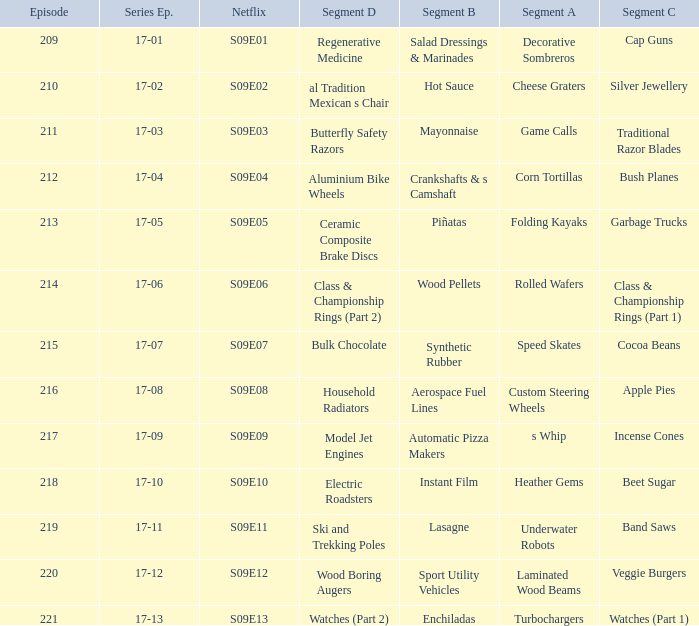Episode smaller than 210 had what segment c? Cap Guns. Help me parse the entirety of this table. {'header': ['Episode', 'Series Ep.', 'Netflix', 'Segment D', 'Segment B', 'Segment A', 'Segment C'], 'rows': [['209', '17-01', 'S09E01', 'Regenerative Medicine', 'Salad Dressings & Marinades', 'Decorative Sombreros', 'Cap Guns'], ['210', '17-02', 'S09E02', 'al Tradition Mexican s Chair', 'Hot Sauce', 'Cheese Graters', 'Silver Jewellery'], ['211', '17-03', 'S09E03', 'Butterfly Safety Razors', 'Mayonnaise', 'Game Calls', 'Traditional Razor Blades'], ['212', '17-04', 'S09E04', 'Aluminium Bike Wheels', 'Crankshafts & s Camshaft', 'Corn Tortillas', 'Bush Planes'], ['213', '17-05', 'S09E05', 'Ceramic Composite Brake Discs', 'Piñatas', 'Folding Kayaks', 'Garbage Trucks'], ['214', '17-06', 'S09E06', 'Class & Championship Rings (Part 2)', 'Wood Pellets', 'Rolled Wafers', 'Class & Championship Rings (Part 1)'], ['215', '17-07', 'S09E07', 'Bulk Chocolate', 'Synthetic Rubber', 'Speed Skates', 'Cocoa Beans'], ['216', '17-08', 'S09E08', 'Household Radiators', 'Aerospace Fuel Lines', 'Custom Steering Wheels', 'Apple Pies'], ['217', '17-09', 'S09E09', 'Model Jet Engines', 'Automatic Pizza Makers', 's Whip', 'Incense Cones'], ['218', '17-10', 'S09E10', 'Electric Roadsters', 'Instant Film', 'Heather Gems', 'Beet Sugar'], ['219', '17-11', 'S09E11', 'Ski and Trekking Poles', 'Lasagne', 'Underwater Robots', 'Band Saws'], ['220', '17-12', 'S09E12', 'Wood Boring Augers', 'Sport Utility Vehicles', 'Laminated Wood Beams', 'Veggie Burgers'], ['221', '17-13', 'S09E13', 'Watches (Part 2)', 'Enchiladas', 'Turbochargers', 'Watches (Part 1)']]} 